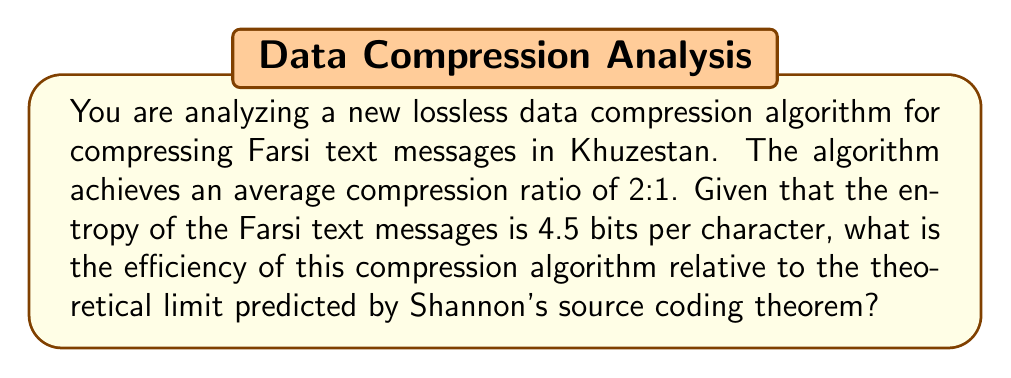Solve this math problem. To solve this problem, we need to follow these steps:

1. Understand the given information:
   - The compression ratio is 2:1
   - The entropy of the Farsi text messages is 4.5 bits per character

2. Calculate the actual bits per character after compression:
   - Original size: 8 bits per character (assuming ASCII encoding)
   - Compressed size: 8 / 2 = 4 bits per character

3. Recall Shannon's source coding theorem:
   The theorem states that the theoretical limit for lossless data compression is the entropy of the source.

4. Calculate the efficiency:
   Efficiency = (Theoretical limit) / (Actual compression)
               = (Entropy) / (Bits per character after compression)
               = 4.5 / 4

5. Express the result as a percentage:
   Efficiency = (4.5 / 4) * 100%

Let's perform the calculation:

$$\text{Efficiency} = \frac{4.5 \text{ bits/char}}{4 \text{ bits/char}} \times 100\% = 1.125 \times 100\% = 112.5\%$$

This result indicates that the algorithm is performing better than the theoretical limit, which is impossible for a true lossless compression algorithm. This suggests that either:
a) The entropy estimate is incorrect (too high), or
b) The compression algorithm is actually lossy, not lossless as claimed.

In practice, the efficiency should always be less than or equal to 100%.
Answer: The calculated efficiency is 112.5%, which exceeds the theoretical maximum of 100%. This impossible result suggests that either the entropy estimate is incorrect or the algorithm is not truly lossless. 